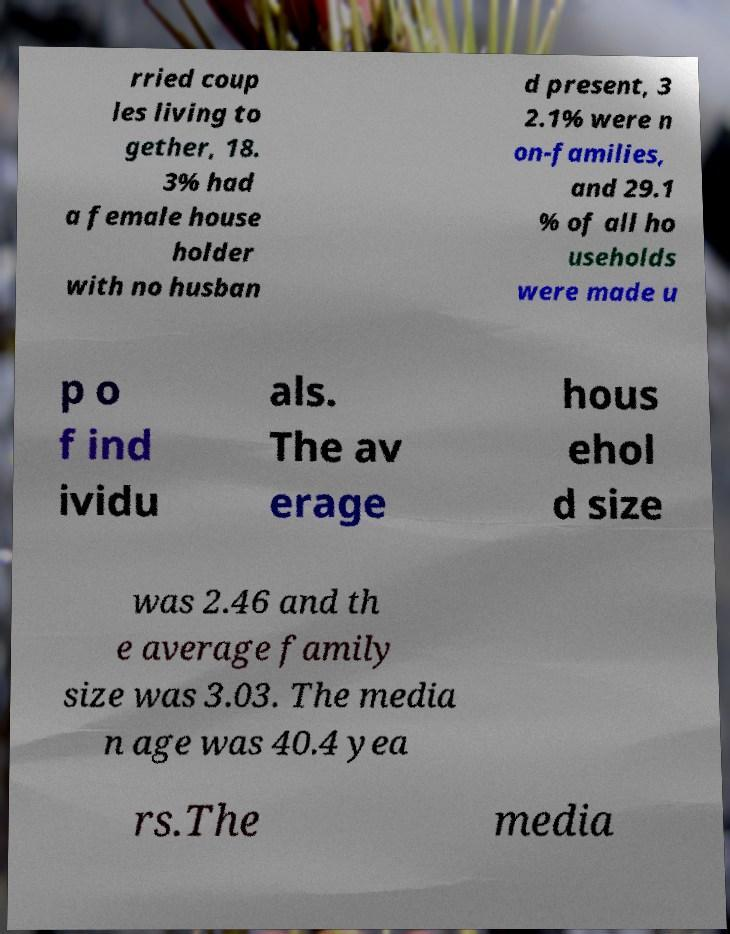For documentation purposes, I need the text within this image transcribed. Could you provide that? rried coup les living to gether, 18. 3% had a female house holder with no husban d present, 3 2.1% were n on-families, and 29.1 % of all ho useholds were made u p o f ind ividu als. The av erage hous ehol d size was 2.46 and th e average family size was 3.03. The media n age was 40.4 yea rs.The media 